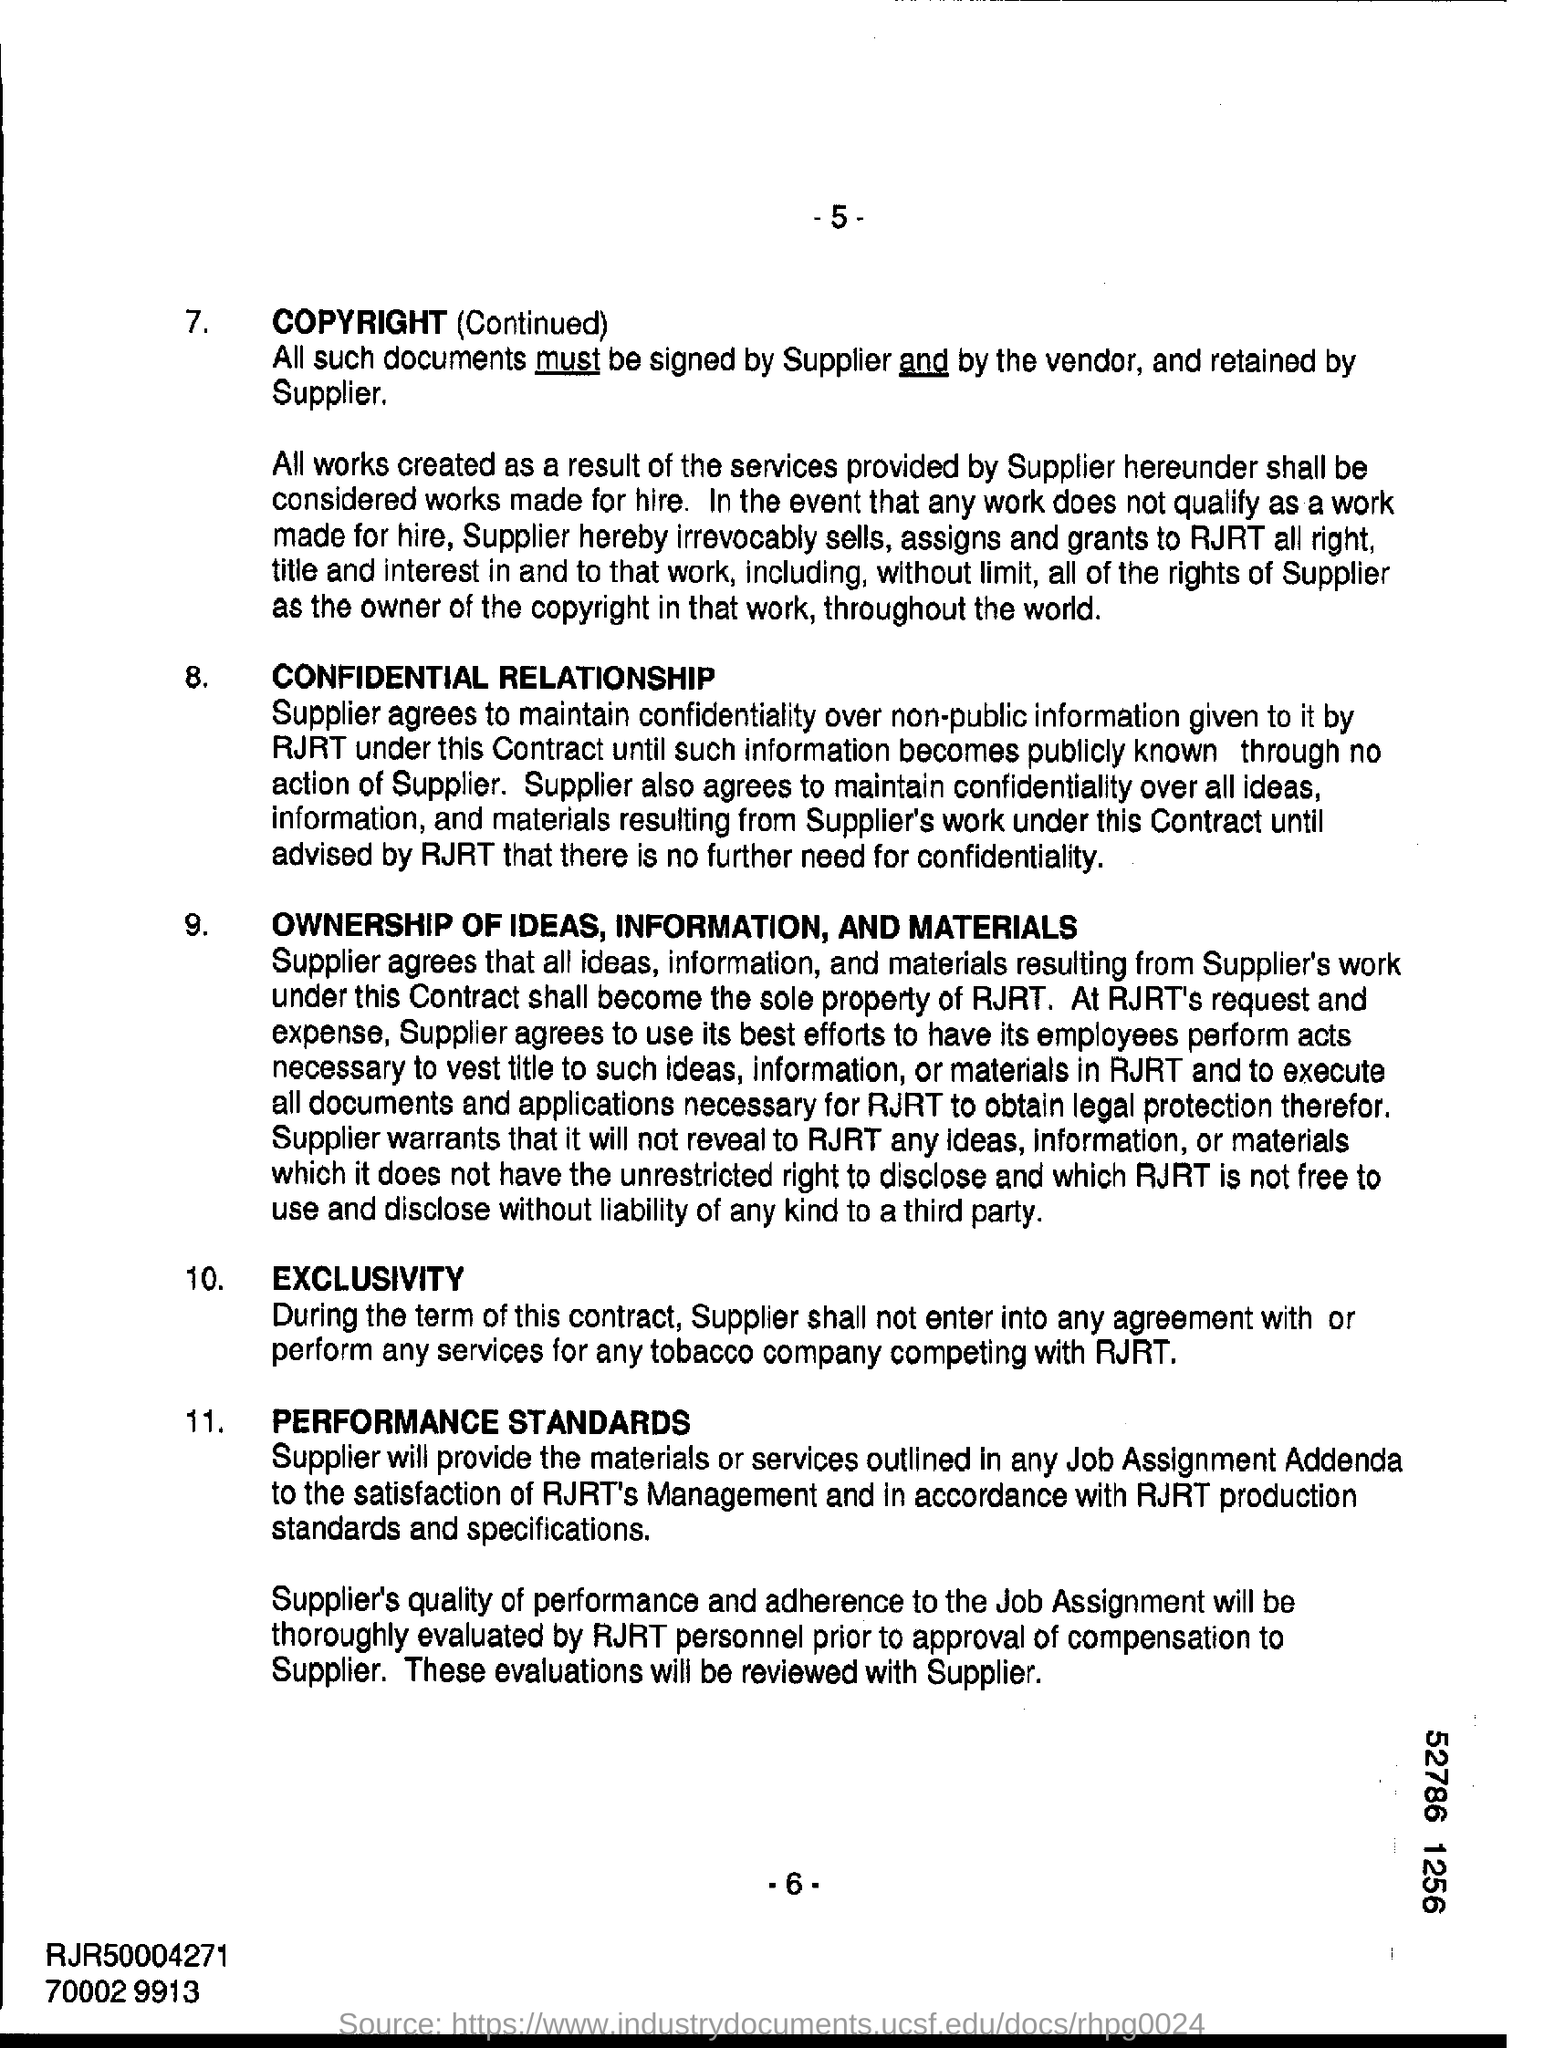The documents must be signed by which two persons?
Give a very brief answer. By supplier and by the vendor. What is the page no mentioned in this document?
Your response must be concise. -6-. 